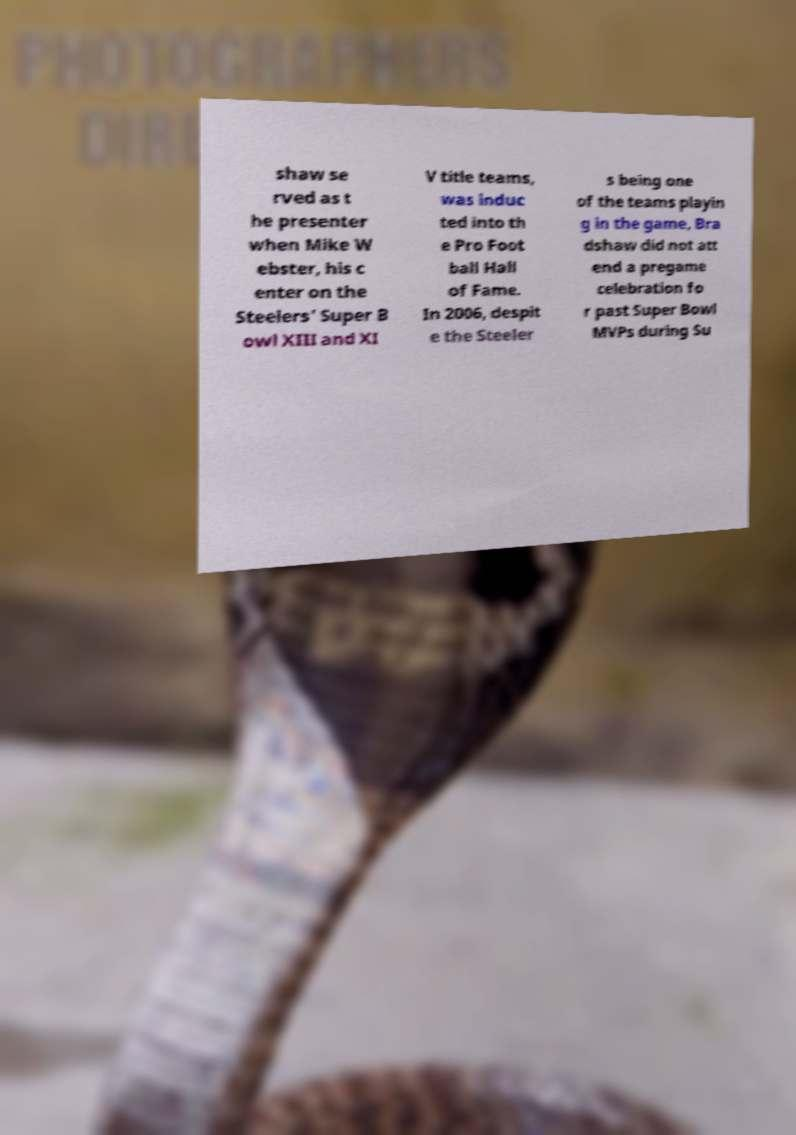Can you read and provide the text displayed in the image?This photo seems to have some interesting text. Can you extract and type it out for me? shaw se rved as t he presenter when Mike W ebster, his c enter on the Steelers' Super B owl XIII and XI V title teams, was induc ted into th e Pro Foot ball Hall of Fame. In 2006, despit e the Steeler s being one of the teams playin g in the game, Bra dshaw did not att end a pregame celebration fo r past Super Bowl MVPs during Su 